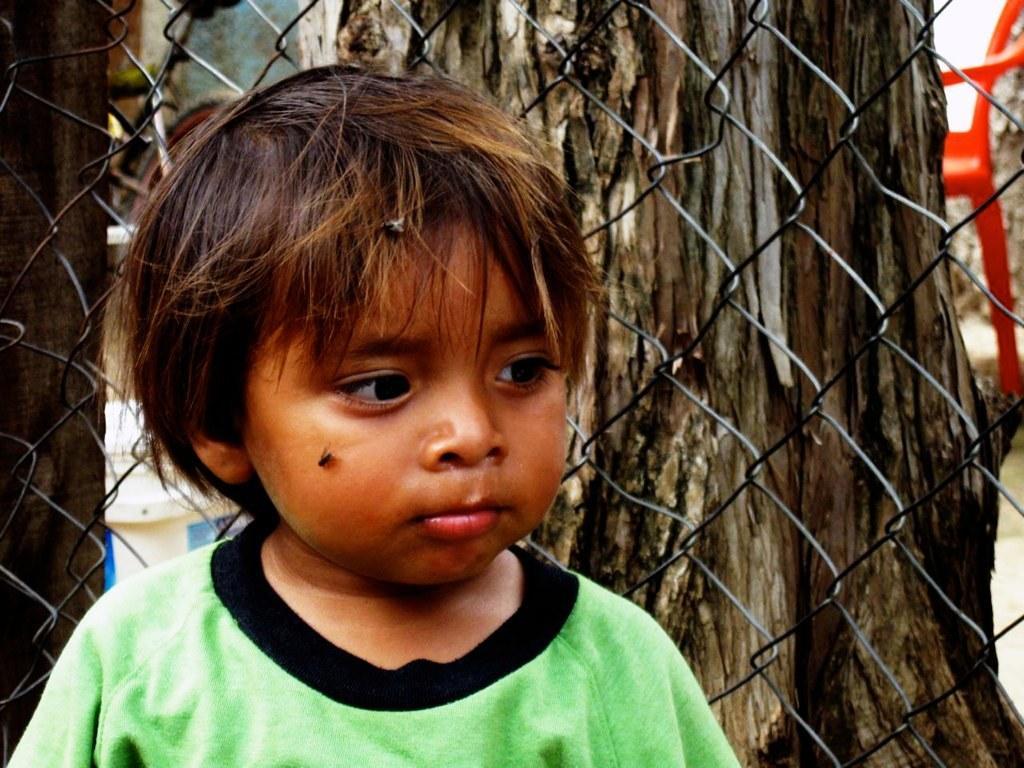In one or two sentences, can you explain what this image depicts? This is a boy with green T-shirt. This looks like a fence. In the background, I can see the tree trunk and a bicycle. This looks like a chair. 